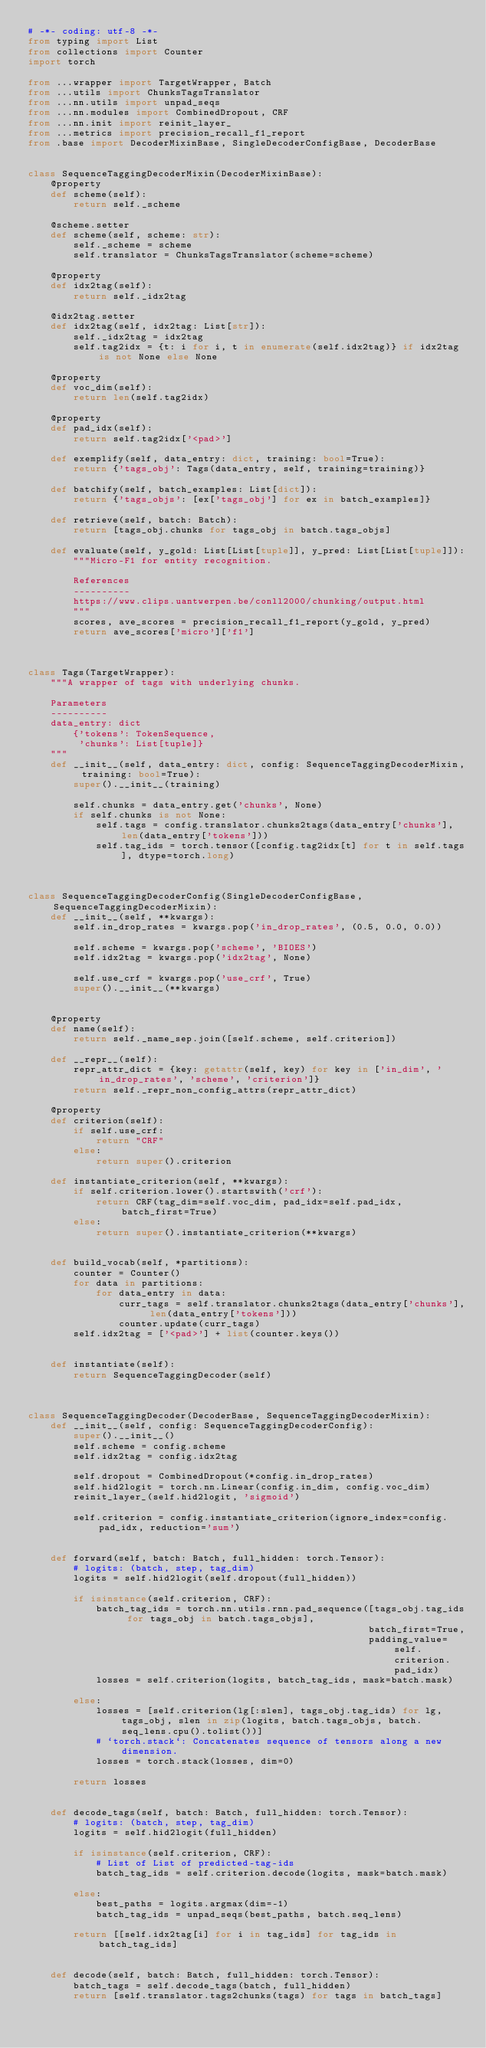<code> <loc_0><loc_0><loc_500><loc_500><_Python_># -*- coding: utf-8 -*-
from typing import List
from collections import Counter
import torch

from ...wrapper import TargetWrapper, Batch
from ...utils import ChunksTagsTranslator
from ...nn.utils import unpad_seqs
from ...nn.modules import CombinedDropout, CRF
from ...nn.init import reinit_layer_
from ...metrics import precision_recall_f1_report
from .base import DecoderMixinBase, SingleDecoderConfigBase, DecoderBase


class SequenceTaggingDecoderMixin(DecoderMixinBase):
    @property
    def scheme(self):
        return self._scheme
        
    @scheme.setter
    def scheme(self, scheme: str):
        self._scheme = scheme
        self.translator = ChunksTagsTranslator(scheme=scheme)
        
    @property
    def idx2tag(self):
        return self._idx2tag
        
    @idx2tag.setter
    def idx2tag(self, idx2tag: List[str]):
        self._idx2tag = idx2tag
        self.tag2idx = {t: i for i, t in enumerate(self.idx2tag)} if idx2tag is not None else None
        
    @property
    def voc_dim(self):
        return len(self.tag2idx)
        
    @property
    def pad_idx(self):
        return self.tag2idx['<pad>']
        
    def exemplify(self, data_entry: dict, training: bool=True):
        return {'tags_obj': Tags(data_entry, self, training=training)}
        
    def batchify(self, batch_examples: List[dict]):
        return {'tags_objs': [ex['tags_obj'] for ex in batch_examples]}
        
    def retrieve(self, batch: Batch):
        return [tags_obj.chunks for tags_obj in batch.tags_objs]
        
    def evaluate(self, y_gold: List[List[tuple]], y_pred: List[List[tuple]]):
        """Micro-F1 for entity recognition. 
        
        References
        ----------
        https://www.clips.uantwerpen.be/conll2000/chunking/output.html
        """
        scores, ave_scores = precision_recall_f1_report(y_gold, y_pred)
        return ave_scores['micro']['f1']



class Tags(TargetWrapper):
    """A wrapper of tags with underlying chunks. 
    
    Parameters
    ----------
    data_entry: dict
        {'tokens': TokenSequence, 
         'chunks': List[tuple]}
    """
    def __init__(self, data_entry: dict, config: SequenceTaggingDecoderMixin, training: bool=True):
        super().__init__(training)
        
        self.chunks = data_entry.get('chunks', None)
        if self.chunks is not None:
            self.tags = config.translator.chunks2tags(data_entry['chunks'], len(data_entry['tokens']))
            self.tag_ids = torch.tensor([config.tag2idx[t] for t in self.tags], dtype=torch.long)



class SequenceTaggingDecoderConfig(SingleDecoderConfigBase, SequenceTaggingDecoderMixin):
    def __init__(self, **kwargs):
        self.in_drop_rates = kwargs.pop('in_drop_rates', (0.5, 0.0, 0.0))
        
        self.scheme = kwargs.pop('scheme', 'BIOES')
        self.idx2tag = kwargs.pop('idx2tag', None)
        
        self.use_crf = kwargs.pop('use_crf', True)
        super().__init__(**kwargs)
        
        
    @property
    def name(self):
        return self._name_sep.join([self.scheme, self.criterion])
        
    def __repr__(self):
        repr_attr_dict = {key: getattr(self, key) for key in ['in_dim', 'in_drop_rates', 'scheme', 'criterion']}
        return self._repr_non_config_attrs(repr_attr_dict)
        
    @property
    def criterion(self):
        if self.use_crf:
            return "CRF"
        else:
            return super().criterion
        
    def instantiate_criterion(self, **kwargs):
        if self.criterion.lower().startswith('crf'):
            return CRF(tag_dim=self.voc_dim, pad_idx=self.pad_idx, batch_first=True)
        else:
            return super().instantiate_criterion(**kwargs)
        
        
    def build_vocab(self, *partitions):
        counter = Counter()
        for data in partitions:
            for data_entry in data:
                curr_tags = self.translator.chunks2tags(data_entry['chunks'], len(data_entry['tokens']))
                counter.update(curr_tags)
        self.idx2tag = ['<pad>'] + list(counter.keys())
        
        
    def instantiate(self):
        return SequenceTaggingDecoder(self)



class SequenceTaggingDecoder(DecoderBase, SequenceTaggingDecoderMixin):
    def __init__(self, config: SequenceTaggingDecoderConfig):
        super().__init__()
        self.scheme = config.scheme
        self.idx2tag = config.idx2tag
        
        self.dropout = CombinedDropout(*config.in_drop_rates)
        self.hid2logit = torch.nn.Linear(config.in_dim, config.voc_dim)
        reinit_layer_(self.hid2logit, 'sigmoid')
        
        self.criterion = config.instantiate_criterion(ignore_index=config.pad_idx, reduction='sum')
        
        
    def forward(self, batch: Batch, full_hidden: torch.Tensor):
        # logits: (batch, step, tag_dim)
        logits = self.hid2logit(self.dropout(full_hidden))
        
        if isinstance(self.criterion, CRF):
            batch_tag_ids = torch.nn.utils.rnn.pad_sequence([tags_obj.tag_ids for tags_obj in batch.tags_objs], 
                                                            batch_first=True, 
                                                            padding_value=self.criterion.pad_idx)
            losses = self.criterion(logits, batch_tag_ids, mask=batch.mask)
            
        else:
            losses = [self.criterion(lg[:slen], tags_obj.tag_ids) for lg, tags_obj, slen in zip(logits, batch.tags_objs, batch.seq_lens.cpu().tolist())]
            # `torch.stack`: Concatenates sequence of tensors along a new dimension. 
            losses = torch.stack(losses, dim=0)
        
        return losses
        
        
    def decode_tags(self, batch: Batch, full_hidden: torch.Tensor):
        # logits: (batch, step, tag_dim)
        logits = self.hid2logit(full_hidden)
        
        if isinstance(self.criterion, CRF):
            # List of List of predicted-tag-ids
            batch_tag_ids = self.criterion.decode(logits, mask=batch.mask)
            
        else:
            best_paths = logits.argmax(dim=-1)
            batch_tag_ids = unpad_seqs(best_paths, batch.seq_lens)
        
        return [[self.idx2tag[i] for i in tag_ids] for tag_ids in batch_tag_ids]
        
        
    def decode(self, batch: Batch, full_hidden: torch.Tensor):
        batch_tags = self.decode_tags(batch, full_hidden)
        return [self.translator.tags2chunks(tags) for tags in batch_tags]
</code> 